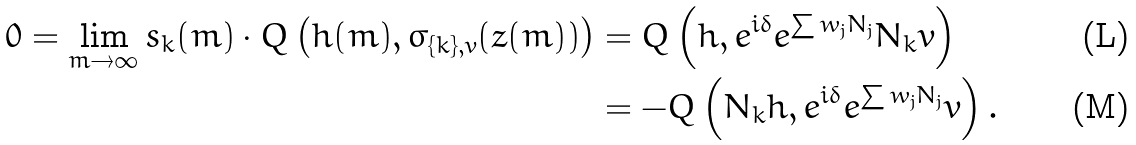Convert formula to latex. <formula><loc_0><loc_0><loc_500><loc_500>0 = \lim _ { m \to \infty } s _ { k } ( m ) \cdot Q \left ( h ( m ) , \sigma _ { \{ k \} , v } ( z ( m ) ) \right ) & = Q \left ( h , e ^ { i \delta } e ^ { \sum w _ { j } N _ { j } } N _ { k } v \right ) \\ & = - Q \left ( N _ { k } h , e ^ { i \delta } e ^ { \sum w _ { j } N _ { j } } v \right ) .</formula> 